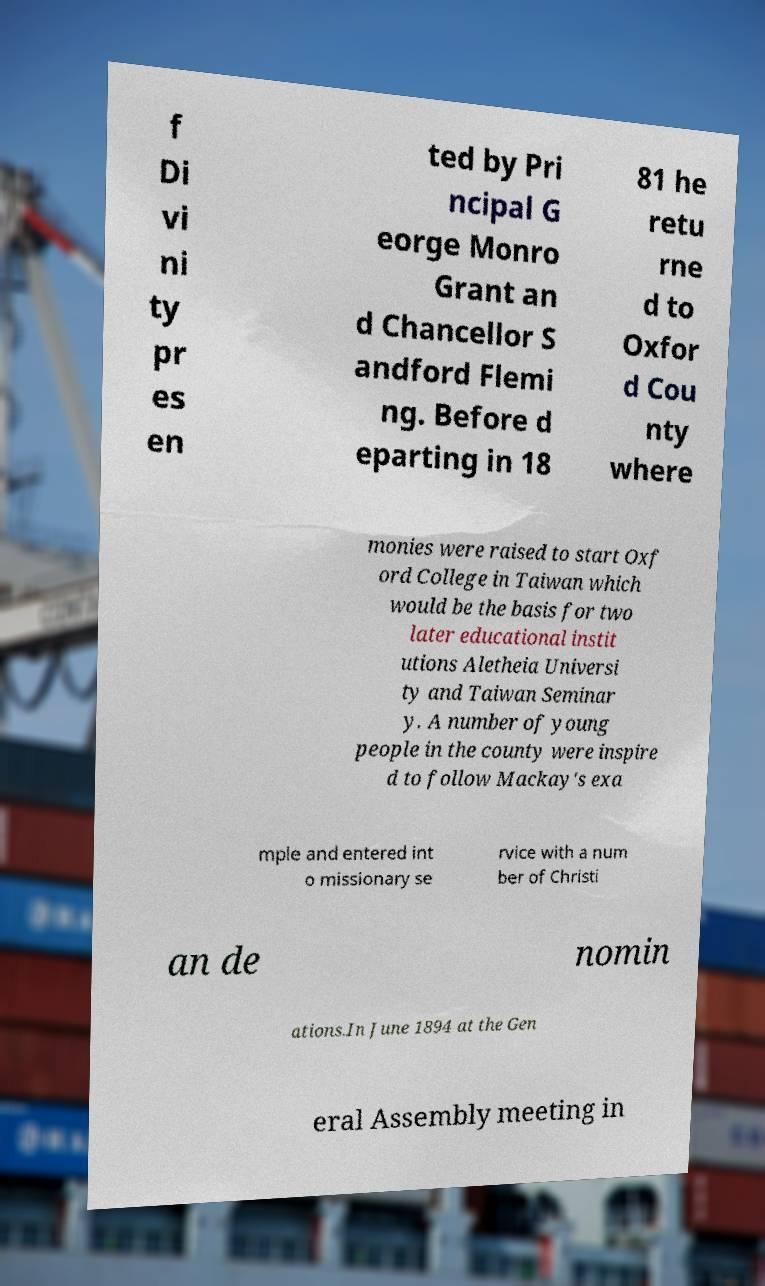Could you assist in decoding the text presented in this image and type it out clearly? f Di vi ni ty pr es en ted by Pri ncipal G eorge Monro Grant an d Chancellor S andford Flemi ng. Before d eparting in 18 81 he retu rne d to Oxfor d Cou nty where monies were raised to start Oxf ord College in Taiwan which would be the basis for two later educational instit utions Aletheia Universi ty and Taiwan Seminar y. A number of young people in the county were inspire d to follow Mackay's exa mple and entered int o missionary se rvice with a num ber of Christi an de nomin ations.In June 1894 at the Gen eral Assembly meeting in 